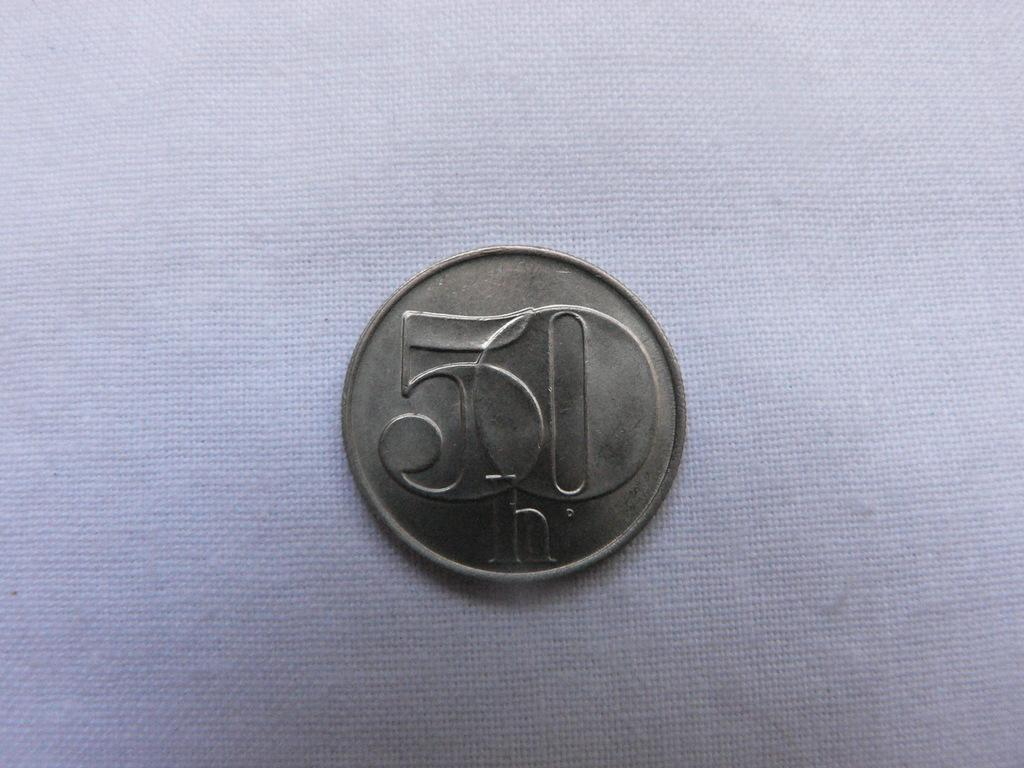What object is the main focus of the image? There is a coin in the image. What can be seen on the surface of the coin? The coin has text engraved on it. What is located beneath the coin in the image? There is a cloth below the coin in the image. What type of error can be seen on the ghost in the image? There is no ghost present in the image, and therefore no errors can be observed. 